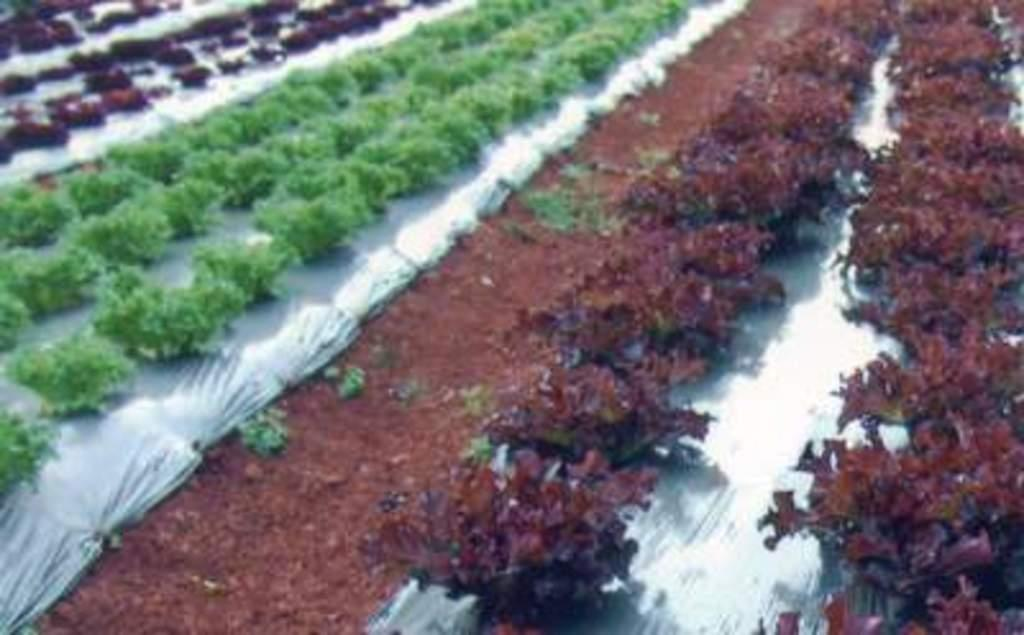What type of living organisms can be seen in the image? Plants can be seen in the image. What is visible at the bottom of the image? There is soil visible at the bottom of the image. What type of material is the cloth made of in the image? The cloth's material cannot be determined from the image. What type of magic is being performed with the plants in the image? There is no indication of any magic being performed in the image; it simply features plants and soil. What list of items is being checked off in the image? There is no list of items present in the image. 